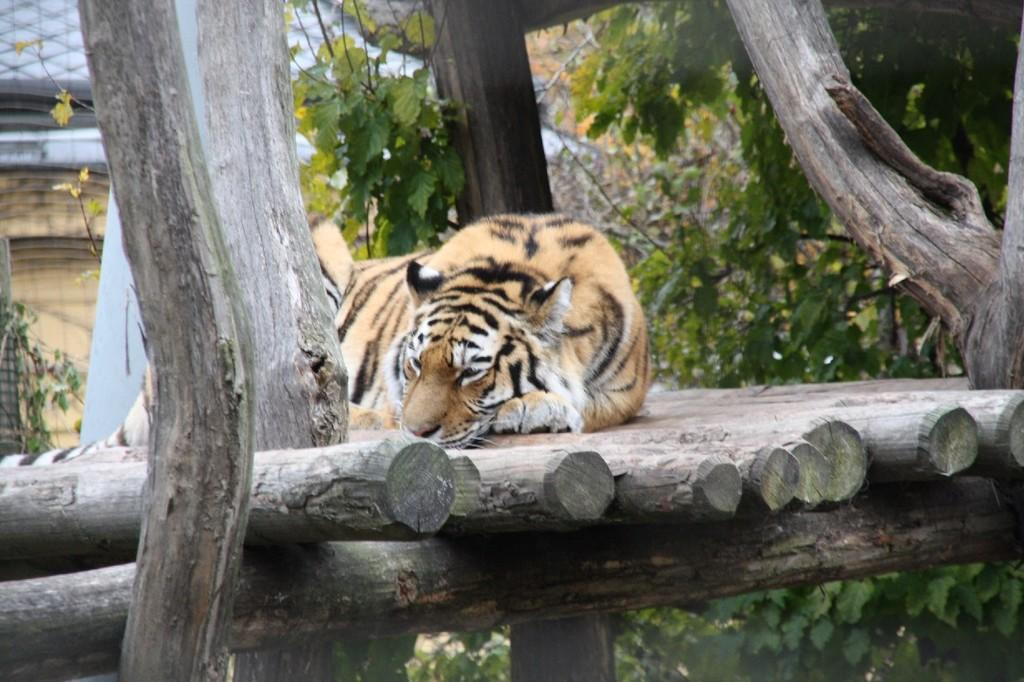What is located in the middle of the image? There is fencing in the middle of the image. What is on the fencing? A tiger is present on the fencing. What can be seen behind the tiger? There are trees visible behind the tiger. What sound can be heard coming from the wilderness in the image? There is no sound present in the image, as it is a still photograph. 